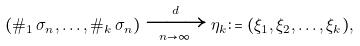<formula> <loc_0><loc_0><loc_500><loc_500>( \# _ { 1 } \, \sigma _ { n } , \dots , \# _ { k } \, \sigma _ { n } ) \xrightarrow [ n \to \infty ] { d } \eta _ { k } \colon = ( \xi _ { 1 } , \xi _ { 2 } , \dots , \xi _ { k } ) ,</formula> 